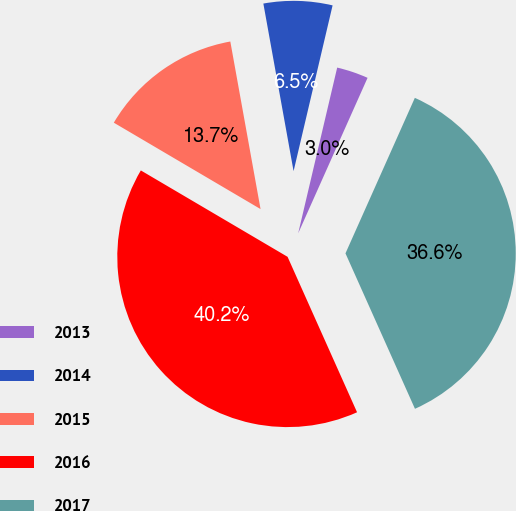<chart> <loc_0><loc_0><loc_500><loc_500><pie_chart><fcel>2013<fcel>2014<fcel>2015<fcel>2016<fcel>2017<nl><fcel>3.0%<fcel>6.52%<fcel>13.69%<fcel>40.16%<fcel>36.63%<nl></chart> 